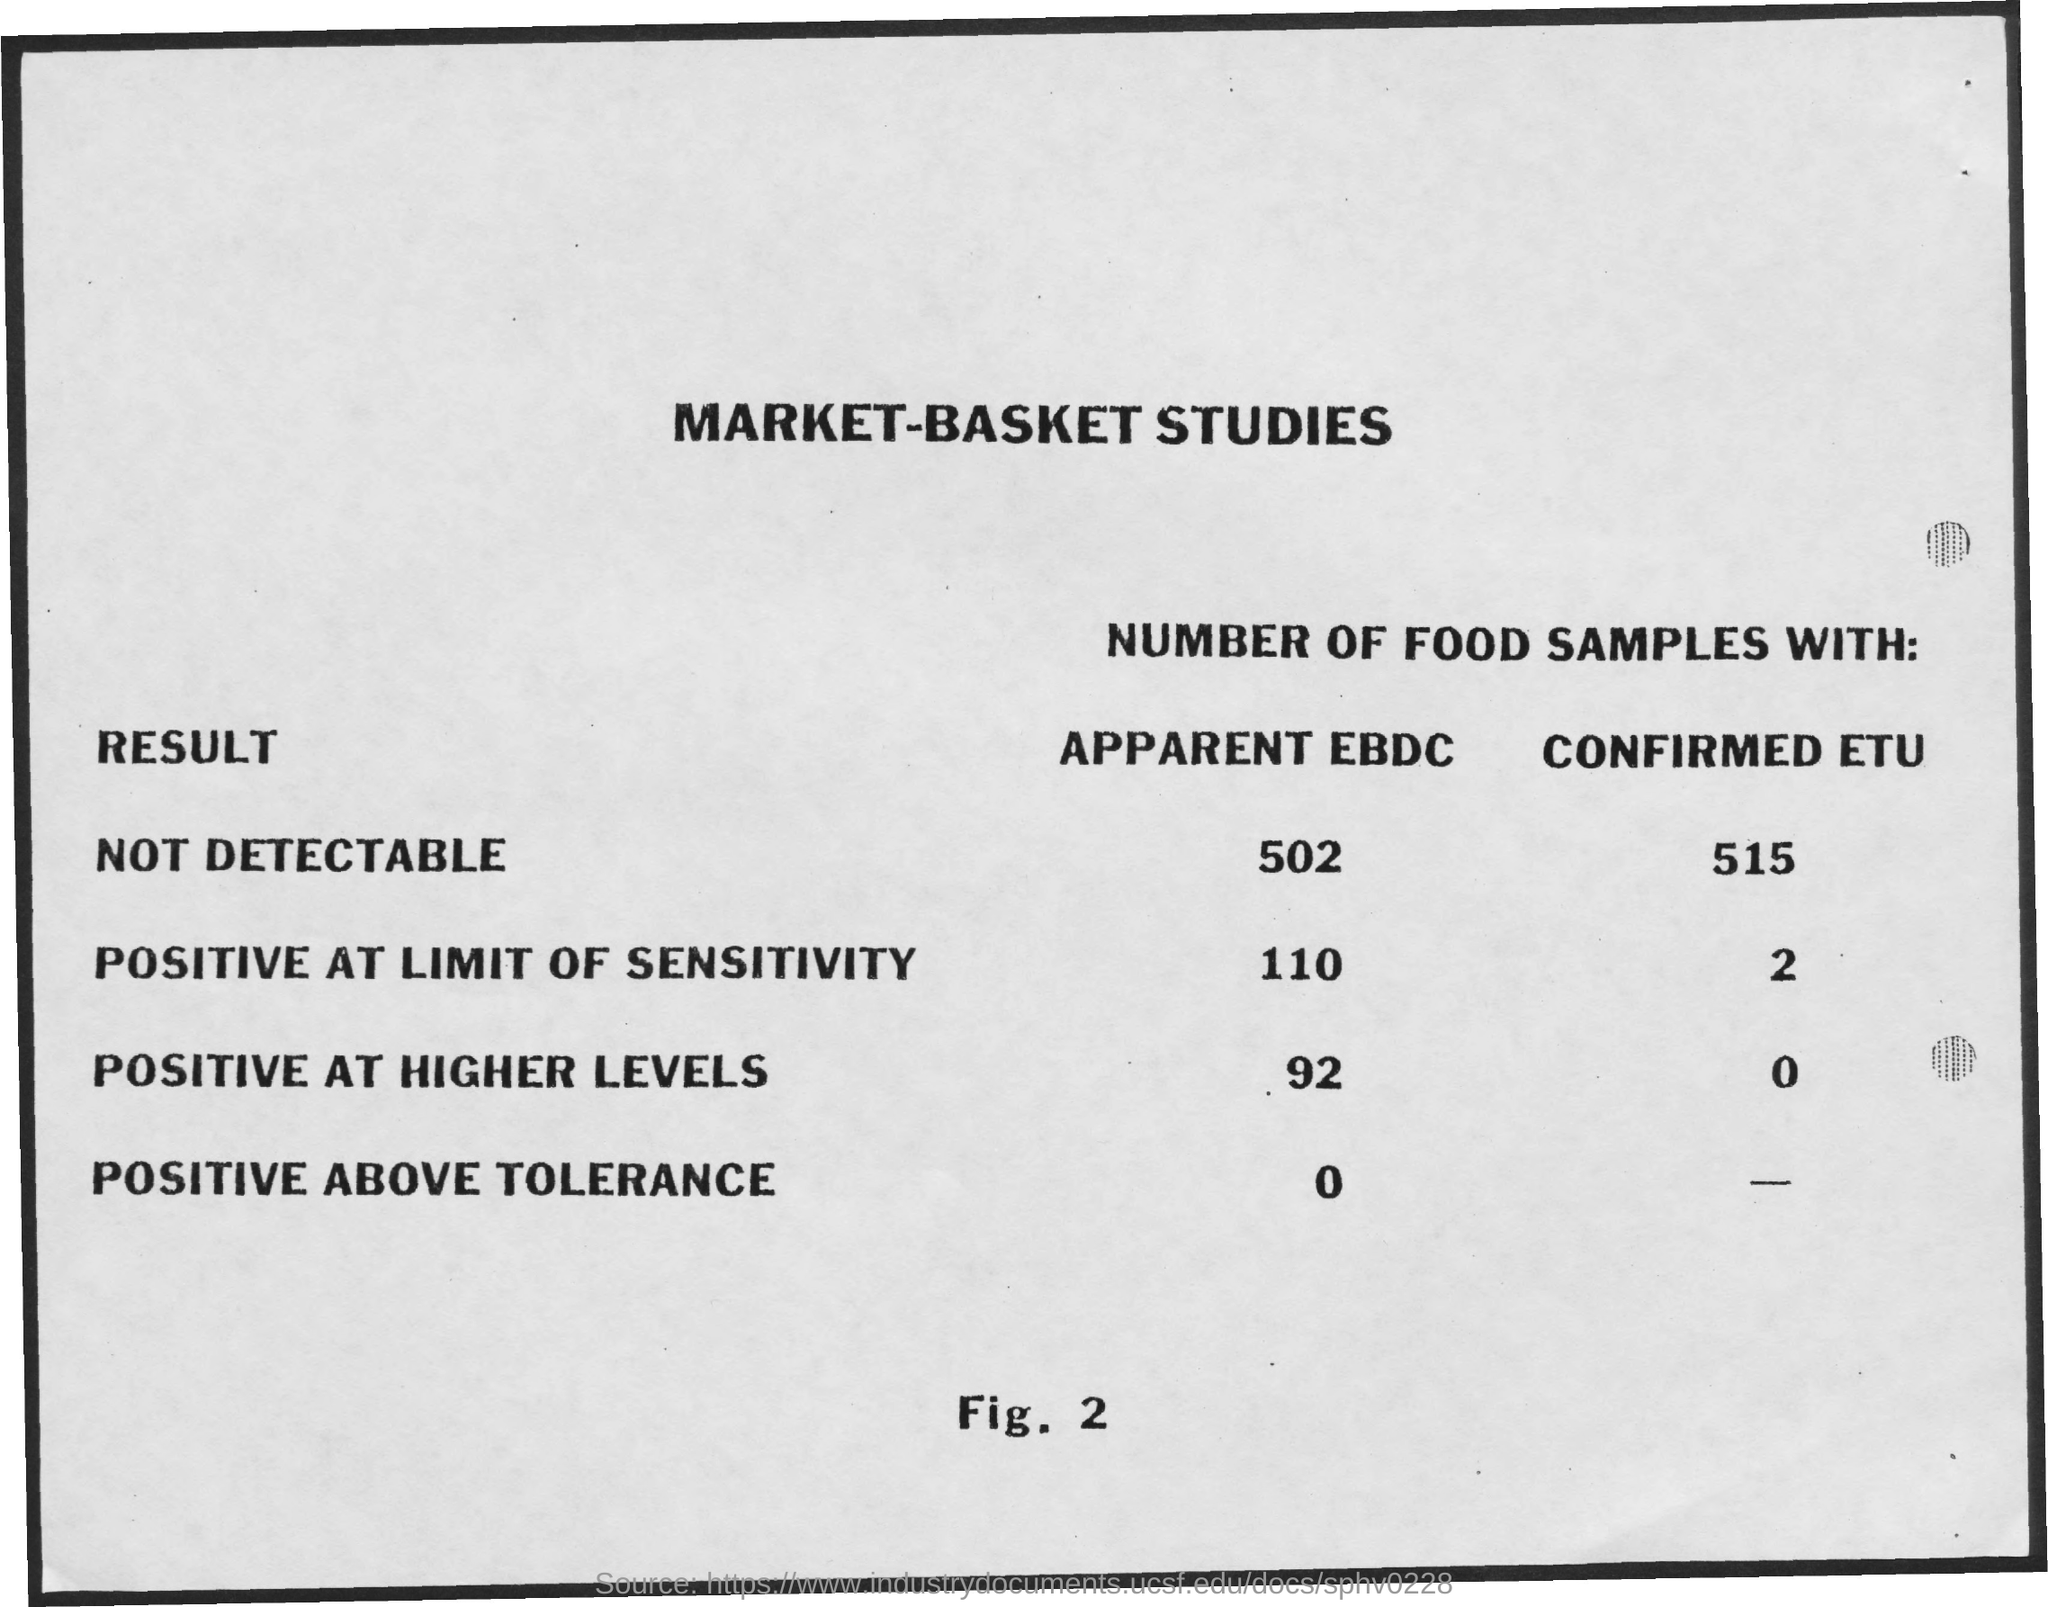What is the Title of the document?
Ensure brevity in your answer.  Market-Basket Studies. What are the number of food samples with apparent EBDC which is Positive at Limit of Sensitivity?
Give a very brief answer. 110. What are the number of food samples with apparent EBDC which is Not Detectable?
Keep it short and to the point. 502. What are the number of food samples with apparent EBDC which is Positive at Higher Levels?
Give a very brief answer. 92. What are the number of food samples with apparent EBDC which is Positive above Tolerance?
Offer a very short reply. 0. What are the number of food samples with Confirmed ETU which is Positive at Limit of Sensitivity?
Ensure brevity in your answer.  2. What are the number of food samples with Confirmed ETU which is Positive at Higher Levels?
Give a very brief answer. 0. What are the number of food samples with Confirmed ETU which is Not Detectable?
Keep it short and to the point. 515. 